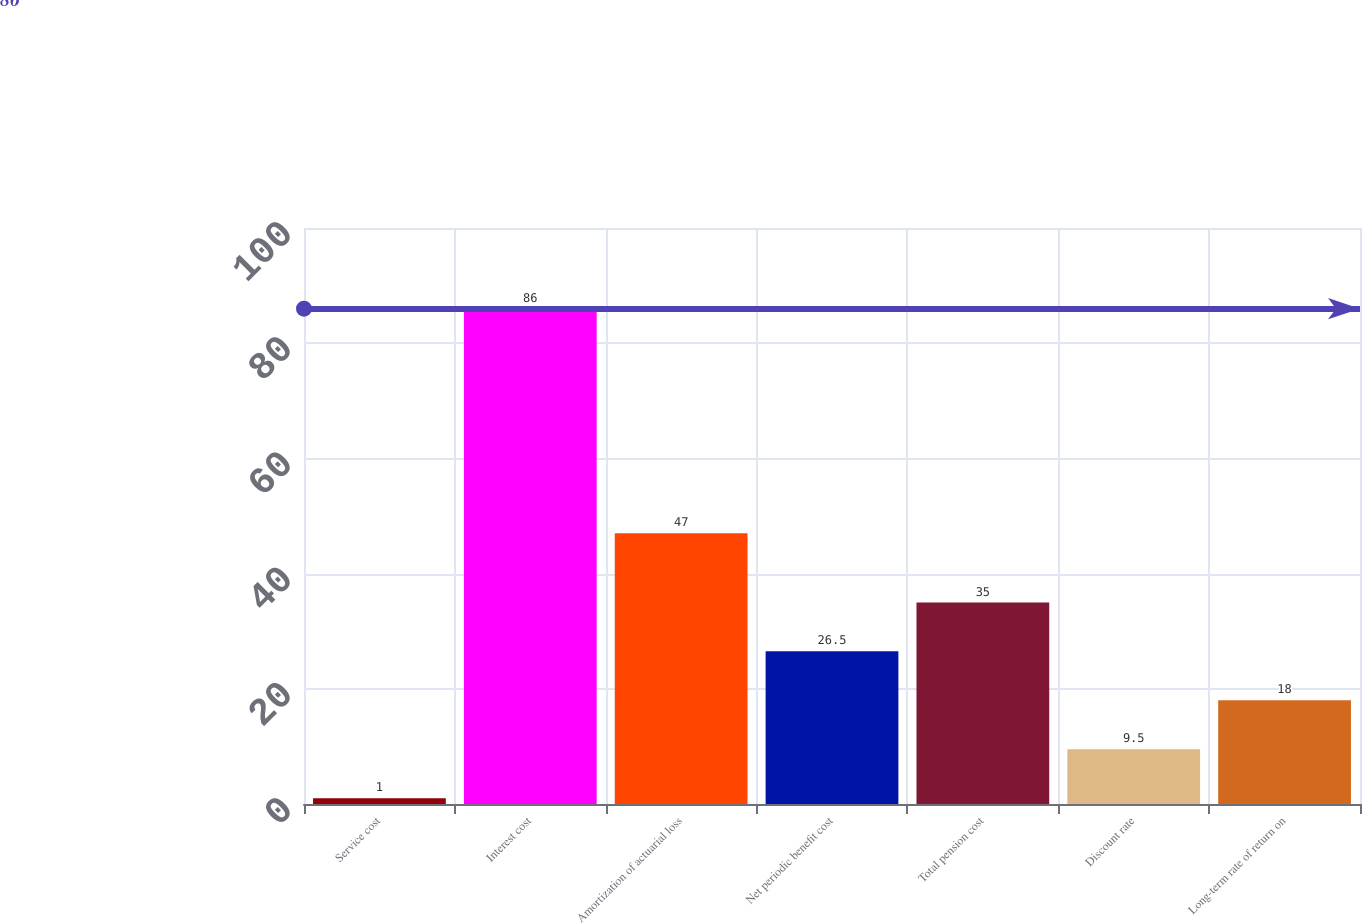Convert chart. <chart><loc_0><loc_0><loc_500><loc_500><bar_chart><fcel>Service cost<fcel>Interest cost<fcel>Amortization of actuarial loss<fcel>Net periodic benefit cost<fcel>Total pension cost<fcel>Discount rate<fcel>Long-term rate of return on<nl><fcel>1<fcel>86<fcel>47<fcel>26.5<fcel>35<fcel>9.5<fcel>18<nl></chart> 